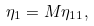<formula> <loc_0><loc_0><loc_500><loc_500>\eta _ { 1 } = M \eta _ { 1 1 } ,</formula> 